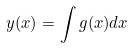Convert formula to latex. <formula><loc_0><loc_0><loc_500><loc_500>y ( x ) = \int g ( x ) d x</formula> 